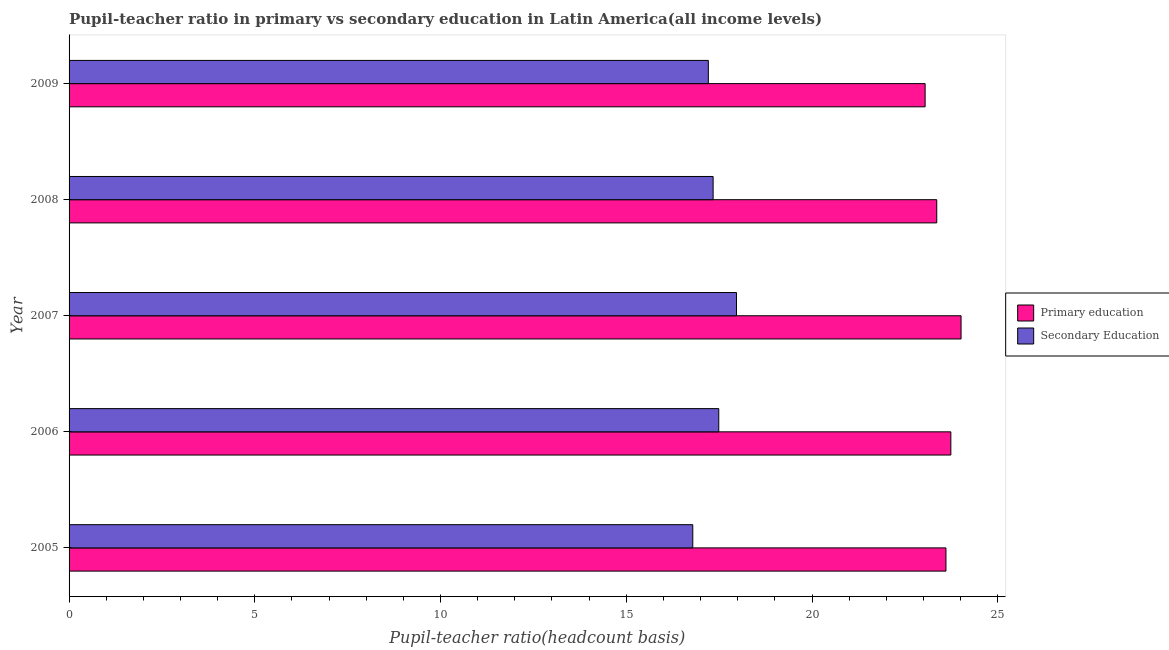How many different coloured bars are there?
Ensure brevity in your answer.  2. How many groups of bars are there?
Offer a terse response. 5. Are the number of bars per tick equal to the number of legend labels?
Your answer should be very brief. Yes. Are the number of bars on each tick of the Y-axis equal?
Provide a succinct answer. Yes. How many bars are there on the 2nd tick from the top?
Offer a very short reply. 2. In how many cases, is the number of bars for a given year not equal to the number of legend labels?
Offer a terse response. 0. What is the pupil teacher ratio on secondary education in 2009?
Make the answer very short. 17.21. Across all years, what is the maximum pupil-teacher ratio in primary education?
Your response must be concise. 24.01. Across all years, what is the minimum pupil teacher ratio on secondary education?
Ensure brevity in your answer.  16.79. In which year was the pupil-teacher ratio in primary education maximum?
Your answer should be compact. 2007. What is the total pupil teacher ratio on secondary education in the graph?
Offer a very short reply. 86.79. What is the difference between the pupil-teacher ratio in primary education in 2006 and that in 2007?
Offer a very short reply. -0.28. What is the difference between the pupil teacher ratio on secondary education in 2009 and the pupil-teacher ratio in primary education in 2005?
Your answer should be compact. -6.4. What is the average pupil-teacher ratio in primary education per year?
Ensure brevity in your answer.  23.55. In the year 2009, what is the difference between the pupil-teacher ratio in primary education and pupil teacher ratio on secondary education?
Offer a very short reply. 5.83. In how many years, is the pupil teacher ratio on secondary education greater than 14 ?
Give a very brief answer. 5. What is the ratio of the pupil teacher ratio on secondary education in 2007 to that in 2008?
Your answer should be compact. 1.04. Is the pupil-teacher ratio in primary education in 2007 less than that in 2009?
Offer a terse response. No. What is the difference between the highest and the second highest pupil-teacher ratio in primary education?
Ensure brevity in your answer.  0.28. What is the difference between the highest and the lowest pupil teacher ratio on secondary education?
Ensure brevity in your answer.  1.18. What does the 1st bar from the top in 2009 represents?
Provide a succinct answer. Secondary Education. What does the 2nd bar from the bottom in 2006 represents?
Your answer should be compact. Secondary Education. How many bars are there?
Give a very brief answer. 10. Are all the bars in the graph horizontal?
Offer a very short reply. Yes. Does the graph contain any zero values?
Offer a terse response. No. Does the graph contain grids?
Provide a short and direct response. No. How many legend labels are there?
Offer a terse response. 2. How are the legend labels stacked?
Your response must be concise. Vertical. What is the title of the graph?
Ensure brevity in your answer.  Pupil-teacher ratio in primary vs secondary education in Latin America(all income levels). Does "Private credit bureau" appear as one of the legend labels in the graph?
Ensure brevity in your answer.  No. What is the label or title of the X-axis?
Offer a very short reply. Pupil-teacher ratio(headcount basis). What is the label or title of the Y-axis?
Your answer should be very brief. Year. What is the Pupil-teacher ratio(headcount basis) of Primary education in 2005?
Give a very brief answer. 23.61. What is the Pupil-teacher ratio(headcount basis) of Secondary Education in 2005?
Provide a short and direct response. 16.79. What is the Pupil-teacher ratio(headcount basis) in Primary education in 2006?
Your answer should be very brief. 23.74. What is the Pupil-teacher ratio(headcount basis) of Secondary Education in 2006?
Your answer should be very brief. 17.49. What is the Pupil-teacher ratio(headcount basis) of Primary education in 2007?
Your answer should be very brief. 24.01. What is the Pupil-teacher ratio(headcount basis) in Secondary Education in 2007?
Ensure brevity in your answer.  17.97. What is the Pupil-teacher ratio(headcount basis) of Primary education in 2008?
Offer a very short reply. 23.36. What is the Pupil-teacher ratio(headcount basis) of Secondary Education in 2008?
Make the answer very short. 17.34. What is the Pupil-teacher ratio(headcount basis) of Primary education in 2009?
Your response must be concise. 23.04. What is the Pupil-teacher ratio(headcount basis) in Secondary Education in 2009?
Your answer should be compact. 17.21. Across all years, what is the maximum Pupil-teacher ratio(headcount basis) of Primary education?
Your response must be concise. 24.01. Across all years, what is the maximum Pupil-teacher ratio(headcount basis) in Secondary Education?
Make the answer very short. 17.97. Across all years, what is the minimum Pupil-teacher ratio(headcount basis) of Primary education?
Provide a succinct answer. 23.04. Across all years, what is the minimum Pupil-teacher ratio(headcount basis) in Secondary Education?
Keep it short and to the point. 16.79. What is the total Pupil-teacher ratio(headcount basis) of Primary education in the graph?
Keep it short and to the point. 117.76. What is the total Pupil-teacher ratio(headcount basis) of Secondary Education in the graph?
Make the answer very short. 86.79. What is the difference between the Pupil-teacher ratio(headcount basis) of Primary education in 2005 and that in 2006?
Ensure brevity in your answer.  -0.13. What is the difference between the Pupil-teacher ratio(headcount basis) of Secondary Education in 2005 and that in 2006?
Provide a short and direct response. -0.7. What is the difference between the Pupil-teacher ratio(headcount basis) of Primary education in 2005 and that in 2007?
Make the answer very short. -0.41. What is the difference between the Pupil-teacher ratio(headcount basis) in Secondary Education in 2005 and that in 2007?
Keep it short and to the point. -1.18. What is the difference between the Pupil-teacher ratio(headcount basis) of Primary education in 2005 and that in 2008?
Provide a short and direct response. 0.25. What is the difference between the Pupil-teacher ratio(headcount basis) in Secondary Education in 2005 and that in 2008?
Ensure brevity in your answer.  -0.55. What is the difference between the Pupil-teacher ratio(headcount basis) of Primary education in 2005 and that in 2009?
Provide a short and direct response. 0.56. What is the difference between the Pupil-teacher ratio(headcount basis) in Secondary Education in 2005 and that in 2009?
Ensure brevity in your answer.  -0.42. What is the difference between the Pupil-teacher ratio(headcount basis) of Primary education in 2006 and that in 2007?
Offer a very short reply. -0.28. What is the difference between the Pupil-teacher ratio(headcount basis) in Secondary Education in 2006 and that in 2007?
Your response must be concise. -0.48. What is the difference between the Pupil-teacher ratio(headcount basis) in Primary education in 2006 and that in 2008?
Provide a short and direct response. 0.38. What is the difference between the Pupil-teacher ratio(headcount basis) in Secondary Education in 2006 and that in 2008?
Give a very brief answer. 0.15. What is the difference between the Pupil-teacher ratio(headcount basis) of Primary education in 2006 and that in 2009?
Your answer should be compact. 0.69. What is the difference between the Pupil-teacher ratio(headcount basis) of Secondary Education in 2006 and that in 2009?
Offer a terse response. 0.28. What is the difference between the Pupil-teacher ratio(headcount basis) in Primary education in 2007 and that in 2008?
Your answer should be very brief. 0.65. What is the difference between the Pupil-teacher ratio(headcount basis) of Secondary Education in 2007 and that in 2008?
Give a very brief answer. 0.63. What is the difference between the Pupil-teacher ratio(headcount basis) in Primary education in 2007 and that in 2009?
Your answer should be compact. 0.97. What is the difference between the Pupil-teacher ratio(headcount basis) in Secondary Education in 2007 and that in 2009?
Keep it short and to the point. 0.76. What is the difference between the Pupil-teacher ratio(headcount basis) of Primary education in 2008 and that in 2009?
Offer a terse response. 0.31. What is the difference between the Pupil-teacher ratio(headcount basis) in Secondary Education in 2008 and that in 2009?
Your answer should be very brief. 0.13. What is the difference between the Pupil-teacher ratio(headcount basis) of Primary education in 2005 and the Pupil-teacher ratio(headcount basis) of Secondary Education in 2006?
Your response must be concise. 6.12. What is the difference between the Pupil-teacher ratio(headcount basis) in Primary education in 2005 and the Pupil-teacher ratio(headcount basis) in Secondary Education in 2007?
Make the answer very short. 5.64. What is the difference between the Pupil-teacher ratio(headcount basis) of Primary education in 2005 and the Pupil-teacher ratio(headcount basis) of Secondary Education in 2008?
Give a very brief answer. 6.27. What is the difference between the Pupil-teacher ratio(headcount basis) of Primary education in 2005 and the Pupil-teacher ratio(headcount basis) of Secondary Education in 2009?
Make the answer very short. 6.4. What is the difference between the Pupil-teacher ratio(headcount basis) of Primary education in 2006 and the Pupil-teacher ratio(headcount basis) of Secondary Education in 2007?
Your answer should be very brief. 5.77. What is the difference between the Pupil-teacher ratio(headcount basis) of Primary education in 2006 and the Pupil-teacher ratio(headcount basis) of Secondary Education in 2008?
Offer a very short reply. 6.4. What is the difference between the Pupil-teacher ratio(headcount basis) of Primary education in 2006 and the Pupil-teacher ratio(headcount basis) of Secondary Education in 2009?
Make the answer very short. 6.53. What is the difference between the Pupil-teacher ratio(headcount basis) of Primary education in 2007 and the Pupil-teacher ratio(headcount basis) of Secondary Education in 2008?
Your answer should be compact. 6.67. What is the difference between the Pupil-teacher ratio(headcount basis) in Primary education in 2007 and the Pupil-teacher ratio(headcount basis) in Secondary Education in 2009?
Provide a succinct answer. 6.8. What is the difference between the Pupil-teacher ratio(headcount basis) of Primary education in 2008 and the Pupil-teacher ratio(headcount basis) of Secondary Education in 2009?
Your response must be concise. 6.15. What is the average Pupil-teacher ratio(headcount basis) of Primary education per year?
Give a very brief answer. 23.55. What is the average Pupil-teacher ratio(headcount basis) in Secondary Education per year?
Provide a succinct answer. 17.36. In the year 2005, what is the difference between the Pupil-teacher ratio(headcount basis) of Primary education and Pupil-teacher ratio(headcount basis) of Secondary Education?
Give a very brief answer. 6.82. In the year 2006, what is the difference between the Pupil-teacher ratio(headcount basis) of Primary education and Pupil-teacher ratio(headcount basis) of Secondary Education?
Ensure brevity in your answer.  6.25. In the year 2007, what is the difference between the Pupil-teacher ratio(headcount basis) in Primary education and Pupil-teacher ratio(headcount basis) in Secondary Education?
Your answer should be very brief. 6.05. In the year 2008, what is the difference between the Pupil-teacher ratio(headcount basis) of Primary education and Pupil-teacher ratio(headcount basis) of Secondary Education?
Ensure brevity in your answer.  6.02. In the year 2009, what is the difference between the Pupil-teacher ratio(headcount basis) of Primary education and Pupil-teacher ratio(headcount basis) of Secondary Education?
Make the answer very short. 5.84. What is the ratio of the Pupil-teacher ratio(headcount basis) in Secondary Education in 2005 to that in 2006?
Provide a short and direct response. 0.96. What is the ratio of the Pupil-teacher ratio(headcount basis) of Primary education in 2005 to that in 2007?
Offer a very short reply. 0.98. What is the ratio of the Pupil-teacher ratio(headcount basis) in Secondary Education in 2005 to that in 2007?
Your response must be concise. 0.93. What is the ratio of the Pupil-teacher ratio(headcount basis) of Primary education in 2005 to that in 2008?
Your answer should be very brief. 1.01. What is the ratio of the Pupil-teacher ratio(headcount basis) of Secondary Education in 2005 to that in 2008?
Keep it short and to the point. 0.97. What is the ratio of the Pupil-teacher ratio(headcount basis) in Primary education in 2005 to that in 2009?
Provide a short and direct response. 1.02. What is the ratio of the Pupil-teacher ratio(headcount basis) in Secondary Education in 2005 to that in 2009?
Make the answer very short. 0.98. What is the ratio of the Pupil-teacher ratio(headcount basis) of Primary education in 2006 to that in 2007?
Your response must be concise. 0.99. What is the ratio of the Pupil-teacher ratio(headcount basis) of Secondary Education in 2006 to that in 2007?
Provide a short and direct response. 0.97. What is the ratio of the Pupil-teacher ratio(headcount basis) in Primary education in 2006 to that in 2008?
Offer a terse response. 1.02. What is the ratio of the Pupil-teacher ratio(headcount basis) in Secondary Education in 2006 to that in 2008?
Provide a short and direct response. 1.01. What is the ratio of the Pupil-teacher ratio(headcount basis) of Primary education in 2006 to that in 2009?
Keep it short and to the point. 1.03. What is the ratio of the Pupil-teacher ratio(headcount basis) in Secondary Education in 2006 to that in 2009?
Provide a succinct answer. 1.02. What is the ratio of the Pupil-teacher ratio(headcount basis) in Primary education in 2007 to that in 2008?
Offer a very short reply. 1.03. What is the ratio of the Pupil-teacher ratio(headcount basis) of Secondary Education in 2007 to that in 2008?
Offer a very short reply. 1.04. What is the ratio of the Pupil-teacher ratio(headcount basis) in Primary education in 2007 to that in 2009?
Make the answer very short. 1.04. What is the ratio of the Pupil-teacher ratio(headcount basis) in Secondary Education in 2007 to that in 2009?
Give a very brief answer. 1.04. What is the ratio of the Pupil-teacher ratio(headcount basis) in Primary education in 2008 to that in 2009?
Offer a terse response. 1.01. What is the ratio of the Pupil-teacher ratio(headcount basis) in Secondary Education in 2008 to that in 2009?
Your answer should be compact. 1.01. What is the difference between the highest and the second highest Pupil-teacher ratio(headcount basis) of Primary education?
Your answer should be compact. 0.28. What is the difference between the highest and the second highest Pupil-teacher ratio(headcount basis) of Secondary Education?
Your answer should be compact. 0.48. What is the difference between the highest and the lowest Pupil-teacher ratio(headcount basis) of Primary education?
Your response must be concise. 0.97. What is the difference between the highest and the lowest Pupil-teacher ratio(headcount basis) of Secondary Education?
Provide a succinct answer. 1.18. 